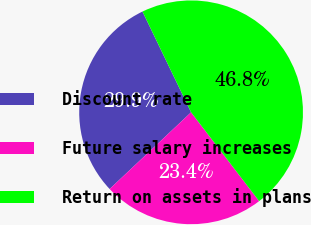<chart> <loc_0><loc_0><loc_500><loc_500><pie_chart><fcel>Discount rate<fcel>Future salary increases<fcel>Return on assets in plans<nl><fcel>29.87%<fcel>23.38%<fcel>46.75%<nl></chart> 